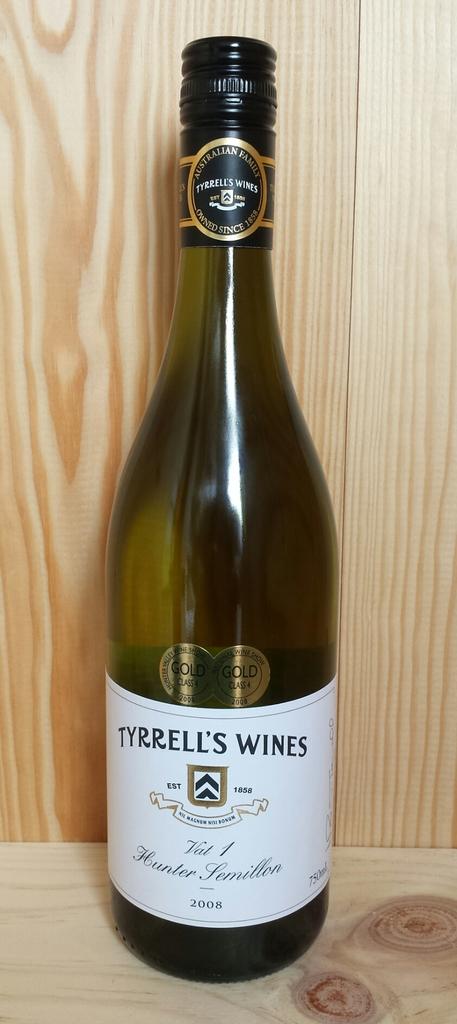What kind of alcohol does tyrrell's sell?
Offer a terse response. Wine. What brand is this wine?
Offer a very short reply. Tyrrell's wines. 